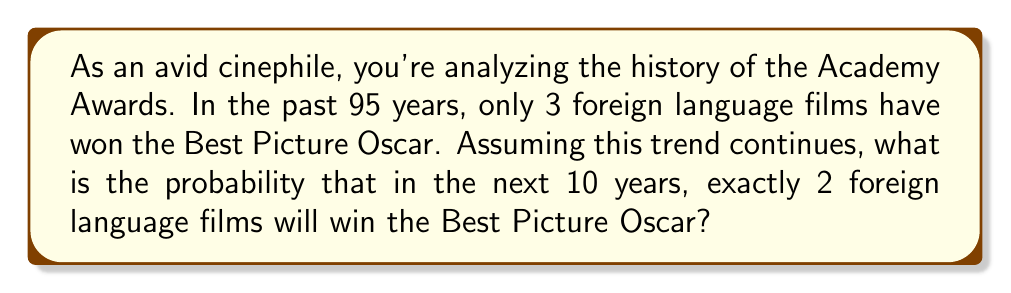Teach me how to tackle this problem. To solve this problem, we'll use the binomial probability distribution, as we're dealing with a fixed number of independent trials (10 years) with two possible outcomes for each trial (foreign language film wins or doesn't win).

Let's define our variables:
$n = 10$ (number of years)
$k = 2$ (number of successes we're interested in)
$p = \frac{3}{95} \approx 0.0316$ (probability of a foreign language film winning in a single year)

The binomial probability formula is:

$$P(X = k) = \binom{n}{k} p^k (1-p)^{n-k}$$

Where $\binom{n}{k}$ is the binomial coefficient, calculated as:

$$\binom{n}{k} = \frac{n!}{k!(n-k)!}$$

Let's calculate each part:

1) $\binom{10}{2} = \frac{10!}{2!(10-2)!} = \frac{10!}{2!8!} = 45$

2) $p^k = (0.0316)^2 \approx 0.001$

3) $(1-p)^{n-k} = (1-0.0316)^{10-2} = (0.9684)^8 \approx 0.7664$

Now, let's put it all together:

$$P(X = 2) = 45 \times 0.001 \times 0.7664 \approx 0.0345$$
Answer: The probability of exactly 2 foreign language films winning the Best Picture Oscar in the next 10 years is approximately 0.0345 or 3.45%. 